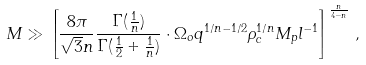Convert formula to latex. <formula><loc_0><loc_0><loc_500><loc_500>M \gg \left [ \frac { 8 \pi } { \sqrt { 3 } n } \frac { \Gamma ( \frac { 1 } { n } ) } { \Gamma ( \frac { 1 } { 2 } + \frac { 1 } { n } ) } \cdot \Omega _ { o } q ^ { 1 / n - 1 / 2 } \rho _ { c } ^ { 1 / n } M _ { p } l ^ { - 1 } \right ] ^ { \frac { n } { 4 - n } } \, ,</formula> 